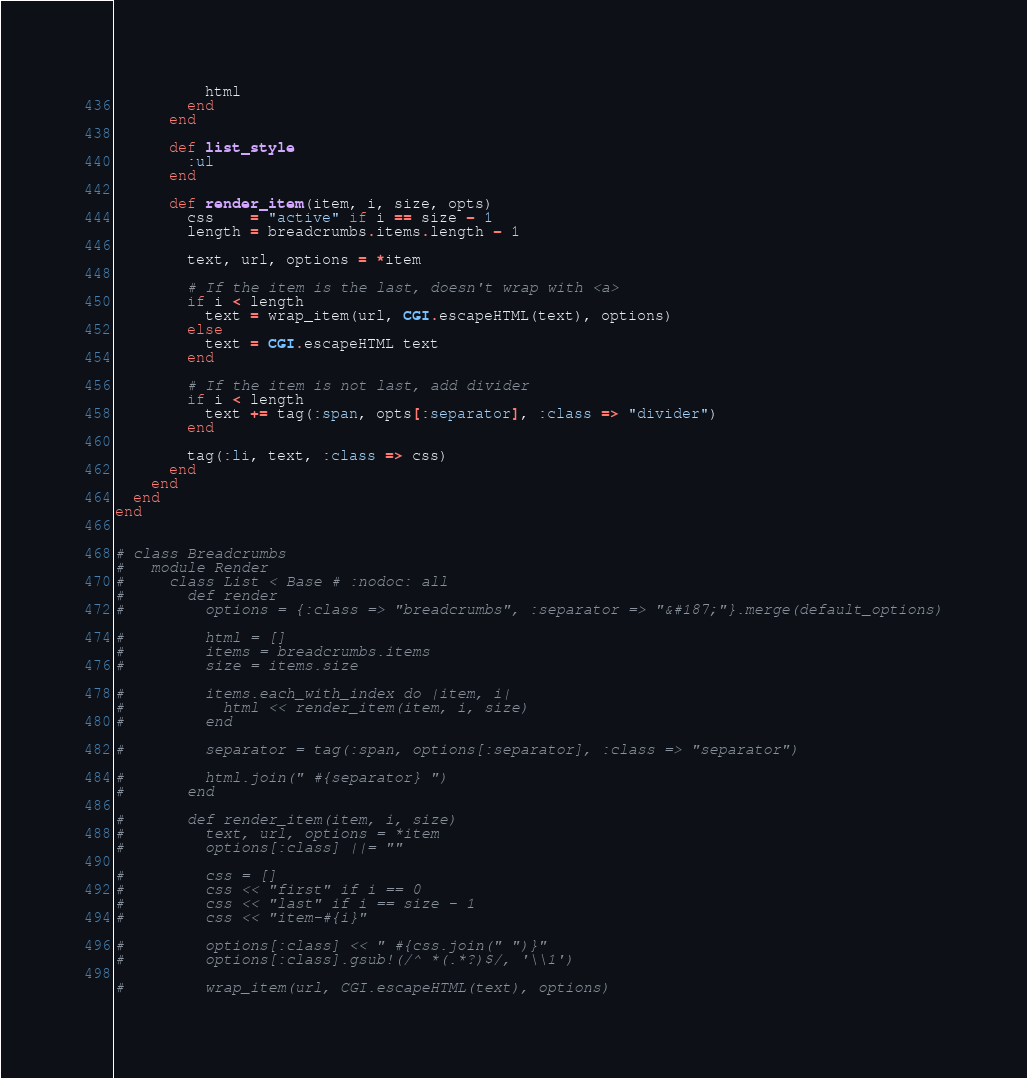<code> <loc_0><loc_0><loc_500><loc_500><_Ruby_>
          html
        end
      end

      def list_style
        :ul
      end

      def render_item(item, i, size, opts)
        css    = "active" if i == size - 1
        length = breadcrumbs.items.length - 1

        text, url, options = *item

        # If the item is the last, doesn't wrap with <a>
        if i < length
          text = wrap_item(url, CGI.escapeHTML(text), options)
        else
          text = CGI.escapeHTML text
        end

        # If the item is not last, add divider
        if i < length
          text += tag(:span, opts[:separator], :class => "divider")
        end

        tag(:li, text, :class => css)
      end
    end
  end
end


# class Breadcrumbs
#   module Render
#     class List < Base # :nodoc: all
#       def render
#         options = {:class => "breadcrumbs", :separator => "&#187;"}.merge(default_options)

#         html = []
#         items = breadcrumbs.items
#         size = items.size

#         items.each_with_index do |item, i|
#           html << render_item(item, i, size)
#         end

#         separator = tag(:span, options[:separator], :class => "separator")

#         html.join(" #{separator} ")
#       end

#       def render_item(item, i, size)
#         text, url, options = *item
#         options[:class] ||= ""

#         css = []
#         css << "first" if i == 0
#         css << "last" if i == size - 1
#         css << "item-#{i}"

#         options[:class] << " #{css.join(" ")}"
#         options[:class].gsub!(/^ *(.*?)$/, '\\1')

#         wrap_item(url, CGI.escapeHTML(text), options)</code> 